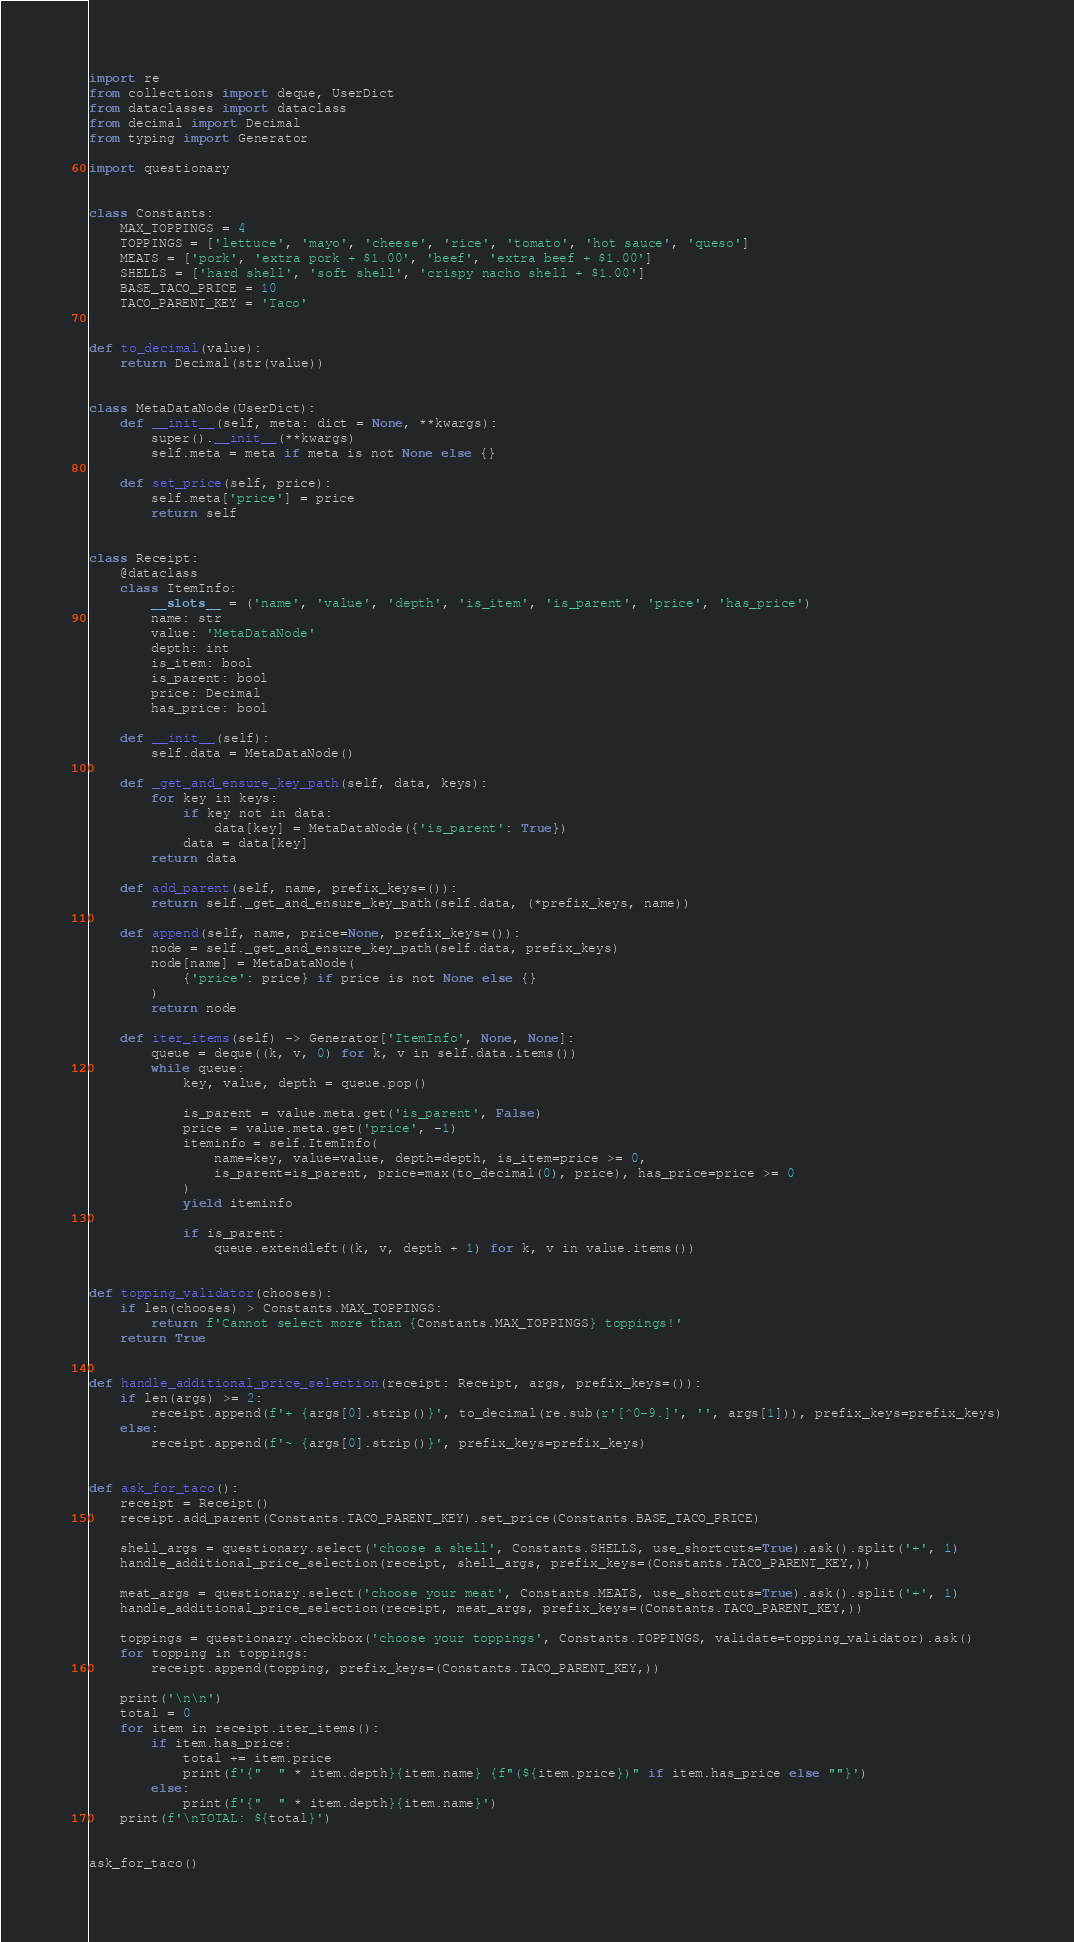<code> <loc_0><loc_0><loc_500><loc_500><_Python_>import re
from collections import deque, UserDict
from dataclasses import dataclass
from decimal import Decimal
from typing import Generator

import questionary


class Constants:
    MAX_TOPPINGS = 4
    TOPPINGS = ['lettuce', 'mayo', 'cheese', 'rice', 'tomato', 'hot sauce', 'queso']
    MEATS = ['pork', 'extra pork + $1.00', 'beef', 'extra beef + $1.00']
    SHELLS = ['hard shell', 'soft shell', 'crispy nacho shell + $1.00']
    BASE_TACO_PRICE = 10
    TACO_PARENT_KEY = 'Taco'


def to_decimal(value):
    return Decimal(str(value))


class MetaDataNode(UserDict):
    def __init__(self, meta: dict = None, **kwargs):
        super().__init__(**kwargs)
        self.meta = meta if meta is not None else {}

    def set_price(self, price):
        self.meta['price'] = price
        return self


class Receipt:
    @dataclass
    class ItemInfo:
        __slots__ = ('name', 'value', 'depth', 'is_item', 'is_parent', 'price', 'has_price')
        name: str
        value: 'MetaDataNode'
        depth: int
        is_item: bool
        is_parent: bool
        price: Decimal
        has_price: bool

    def __init__(self):
        self.data = MetaDataNode()

    def _get_and_ensure_key_path(self, data, keys):
        for key in keys:
            if key not in data:
                data[key] = MetaDataNode({'is_parent': True})
            data = data[key]
        return data

    def add_parent(self, name, prefix_keys=()):
        return self._get_and_ensure_key_path(self.data, (*prefix_keys, name))

    def append(self, name, price=None, prefix_keys=()):
        node = self._get_and_ensure_key_path(self.data, prefix_keys)
        node[name] = MetaDataNode(
            {'price': price} if price is not None else {}
        )
        return node

    def iter_items(self) -> Generator['ItemInfo', None, None]:
        queue = deque((k, v, 0) for k, v in self.data.items())
        while queue:
            key, value, depth = queue.pop()

            is_parent = value.meta.get('is_parent', False)
            price = value.meta.get('price', -1)
            iteminfo = self.ItemInfo(
                name=key, value=value, depth=depth, is_item=price >= 0,
                is_parent=is_parent, price=max(to_decimal(0), price), has_price=price >= 0
            )
            yield iteminfo

            if is_parent:
                queue.extendleft((k, v, depth + 1) for k, v in value.items())


def topping_validator(chooses):
    if len(chooses) > Constants.MAX_TOPPINGS:
        return f'Cannot select more than {Constants.MAX_TOPPINGS} toppings!'
    return True


def handle_additional_price_selection(receipt: Receipt, args, prefix_keys=()):
    if len(args) >= 2:
        receipt.append(f'+ {args[0].strip()}', to_decimal(re.sub(r'[^0-9.]', '', args[1])), prefix_keys=prefix_keys)
    else:
        receipt.append(f'~ {args[0].strip()}', prefix_keys=prefix_keys)


def ask_for_taco():
    receipt = Receipt()
    receipt.add_parent(Constants.TACO_PARENT_KEY).set_price(Constants.BASE_TACO_PRICE)

    shell_args = questionary.select('choose a shell', Constants.SHELLS, use_shortcuts=True).ask().split('+', 1)
    handle_additional_price_selection(receipt, shell_args, prefix_keys=(Constants.TACO_PARENT_KEY,))

    meat_args = questionary.select('choose your meat', Constants.MEATS, use_shortcuts=True).ask().split('+', 1)
    handle_additional_price_selection(receipt, meat_args, prefix_keys=(Constants.TACO_PARENT_KEY,))

    toppings = questionary.checkbox('choose your toppings', Constants.TOPPINGS, validate=topping_validator).ask()
    for topping in toppings:
        receipt.append(topping, prefix_keys=(Constants.TACO_PARENT_KEY,))

    print('\n\n')
    total = 0
    for item in receipt.iter_items():
        if item.has_price:
            total += item.price
            print(f'{"  " * item.depth}{item.name} {f"(${item.price})" if item.has_price else ""}')
        else:
            print(f'{"  " * item.depth}{item.name}')
    print(f'\nTOTAL: ${total}')


ask_for_taco()
</code> 